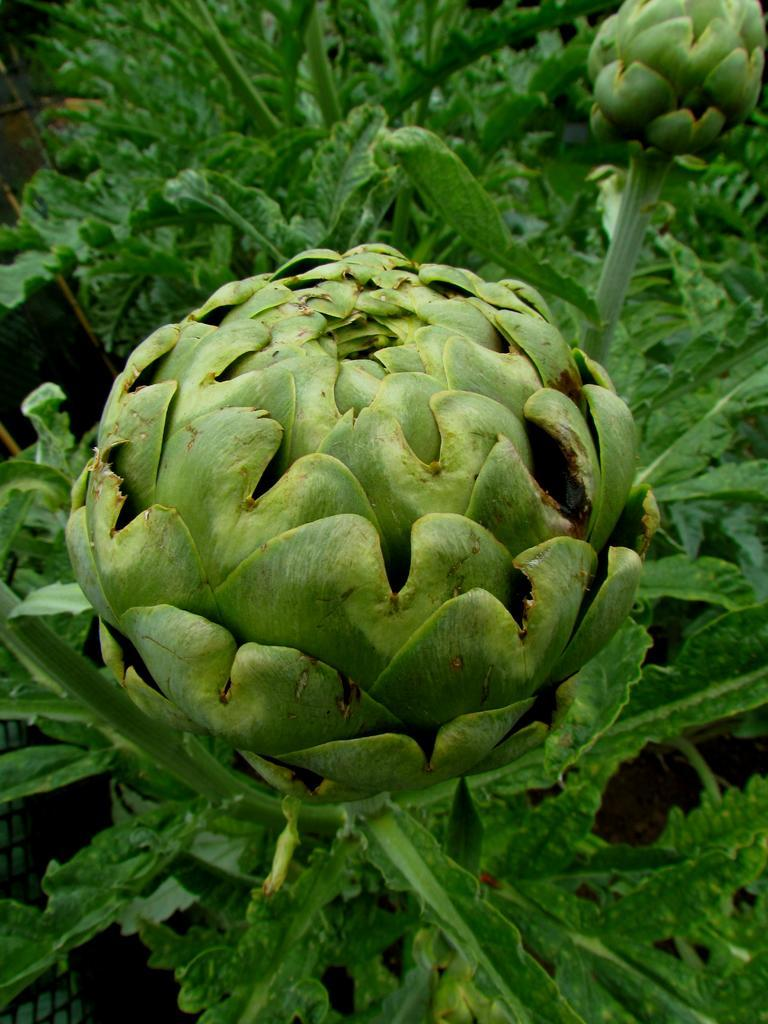What type of plants are visible in the image? There are green plants in the image. What stage of growth are the plants in the image? There are green buds in the image, which suggests they are in an early stage of growth. Can you see a rifle among the green plants in the image? No, there is no rifle present among the green plants in the image. Is there a minister standing near the green plants in the image? No, there is no minister present near the green plants in the image. 